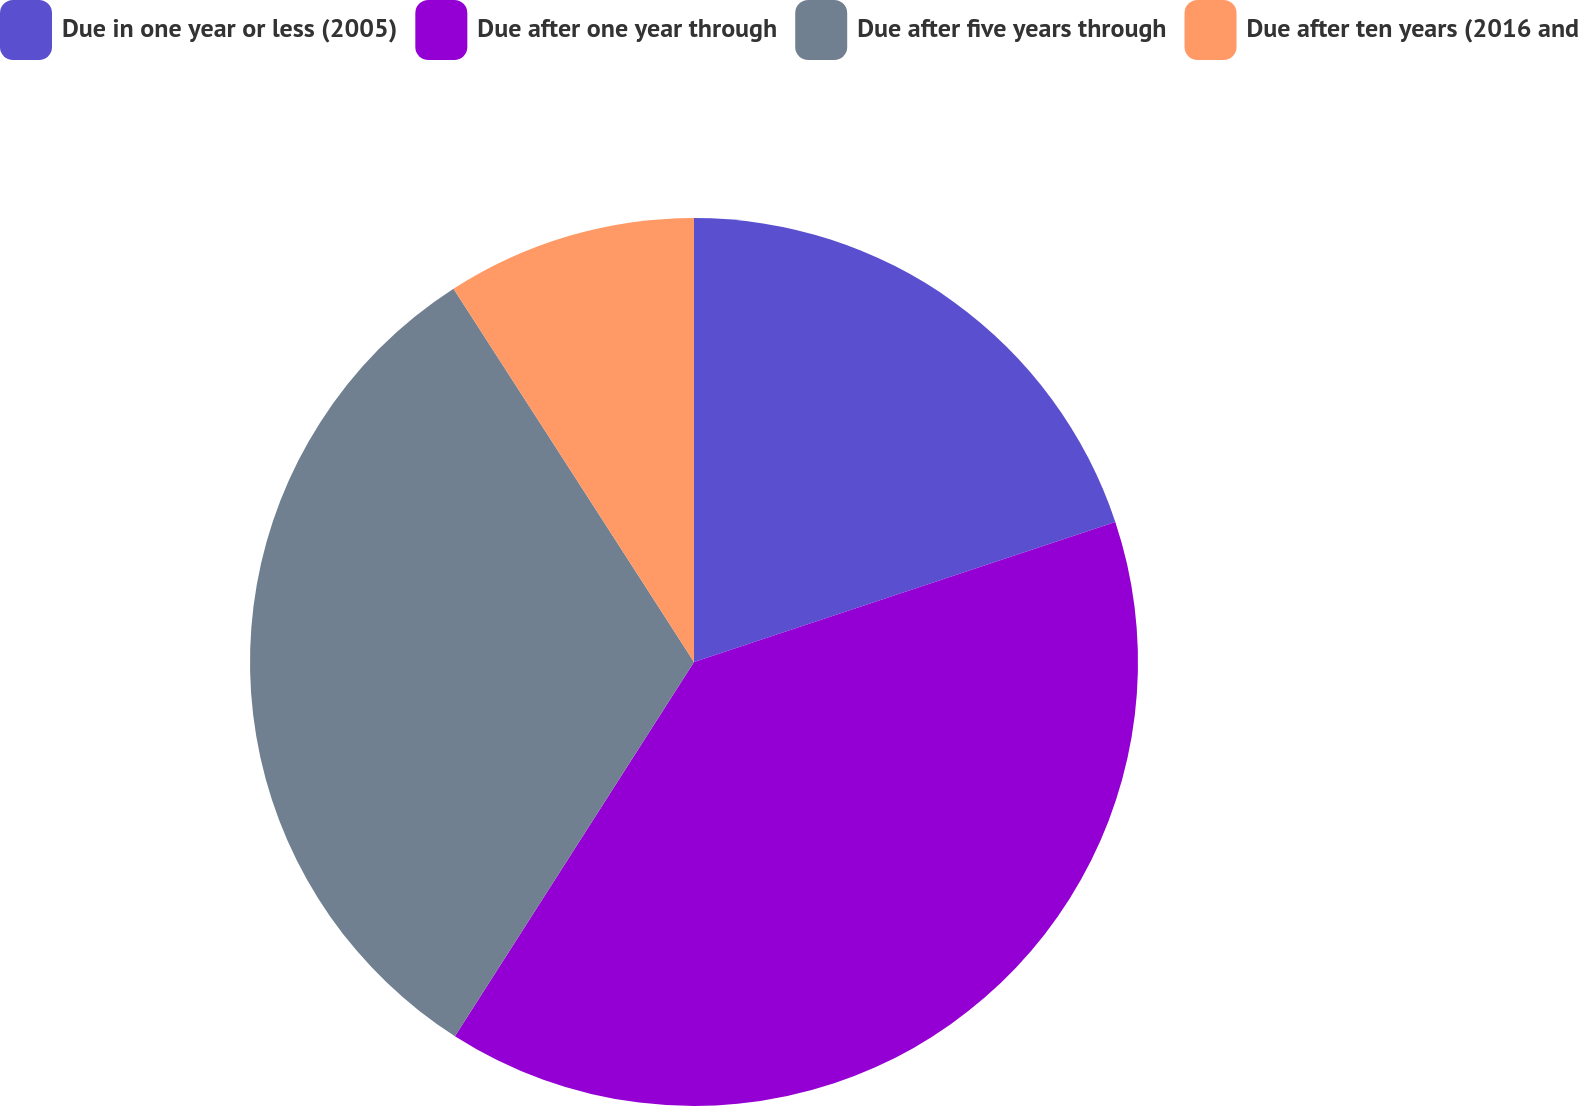<chart> <loc_0><loc_0><loc_500><loc_500><pie_chart><fcel>Due in one year or less (2005)<fcel>Due after one year through<fcel>Due after five years through<fcel>Due after ten years (2016 and<nl><fcel>19.89%<fcel>39.16%<fcel>31.84%<fcel>9.11%<nl></chart> 